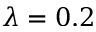<formula> <loc_0><loc_0><loc_500><loc_500>\lambda = 0 . 2</formula> 